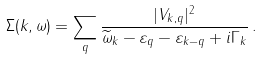<formula> <loc_0><loc_0><loc_500><loc_500>\Sigma ( { k } , \omega ) = \sum _ { q } \frac { | V _ { { k } , { q } } | ^ { 2 } } { \widetilde { \omega } _ { k } - \varepsilon _ { q } - \varepsilon _ { { k } - { q } } + i \Gamma _ { k } } \, .</formula> 